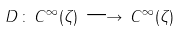<formula> <loc_0><loc_0><loc_500><loc_500>D \, \colon \, C ^ { \infty } ( \zeta ) \, \longrightarrow \, C ^ { \infty } ( \zeta )</formula> 